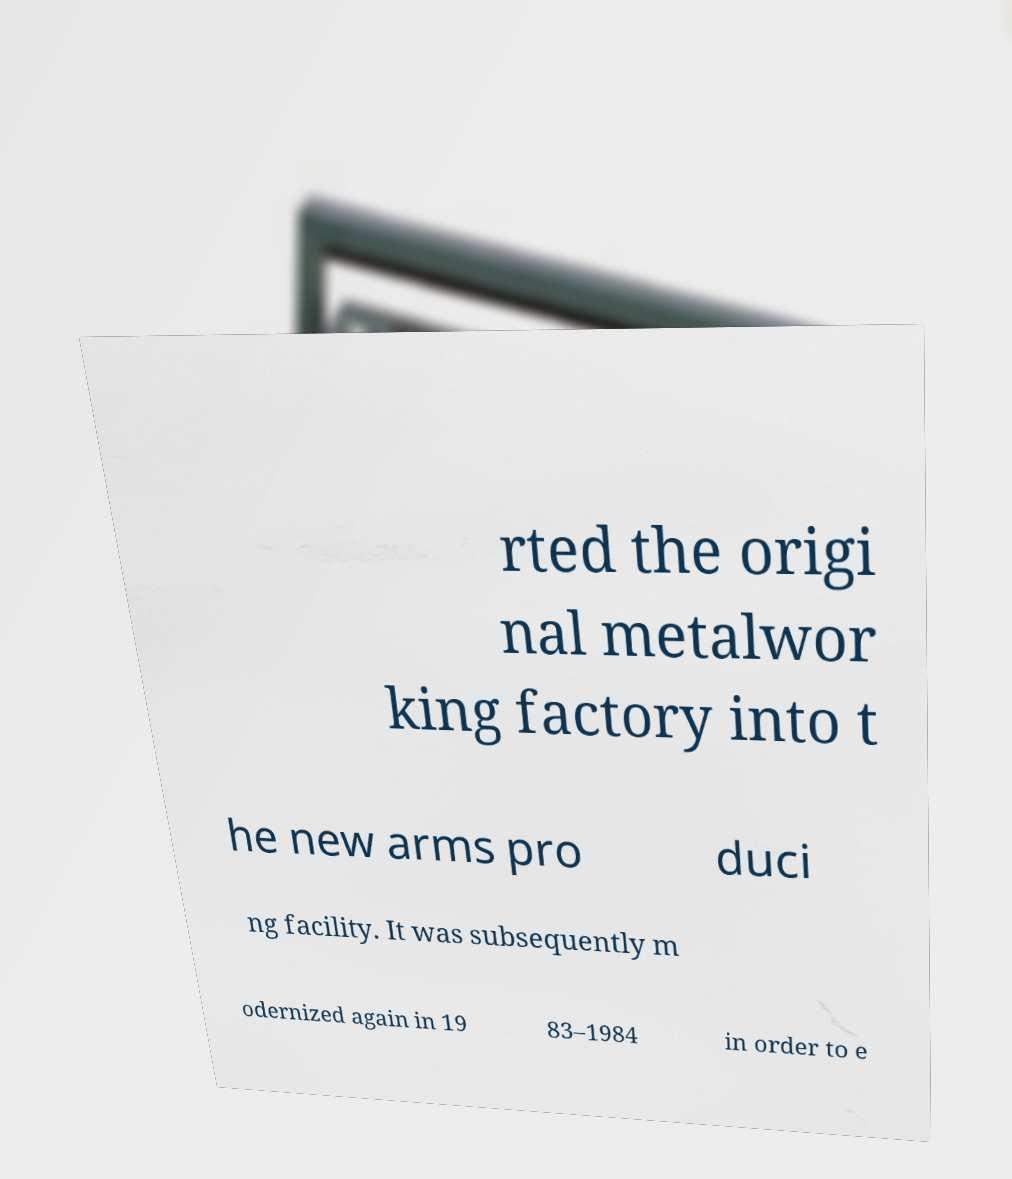Could you extract and type out the text from this image? rted the origi nal metalwor king factory into t he new arms pro duci ng facility. It was subsequently m odernized again in 19 83–1984 in order to e 